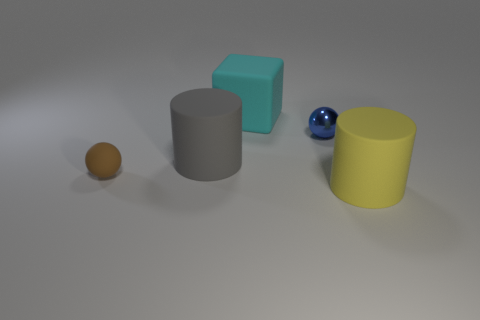Does the large matte object that is to the left of the cyan block have the same shape as the tiny thing that is behind the brown rubber ball?
Your answer should be very brief. No. What number of objects are either big gray shiny cubes or big cylinders in front of the rubber sphere?
Provide a short and direct response. 1. What number of other objects are the same shape as the big cyan rubber object?
Provide a succinct answer. 0. Do the big cylinder that is in front of the large gray matte cylinder and the blue thing have the same material?
Your answer should be compact. No. What number of objects are either small red rubber blocks or yellow cylinders?
Your answer should be very brief. 1. There is another object that is the same shape as the large gray thing; what size is it?
Ensure brevity in your answer.  Large. The matte cube is what size?
Keep it short and to the point. Large. Is the number of blue metal spheres that are to the left of the cyan rubber thing greater than the number of metal objects?
Your answer should be compact. No. Is there anything else that has the same material as the small blue object?
Ensure brevity in your answer.  No. There is a tiny sphere in front of the gray cylinder; is it the same color as the cylinder that is behind the big yellow rubber cylinder?
Ensure brevity in your answer.  No. 